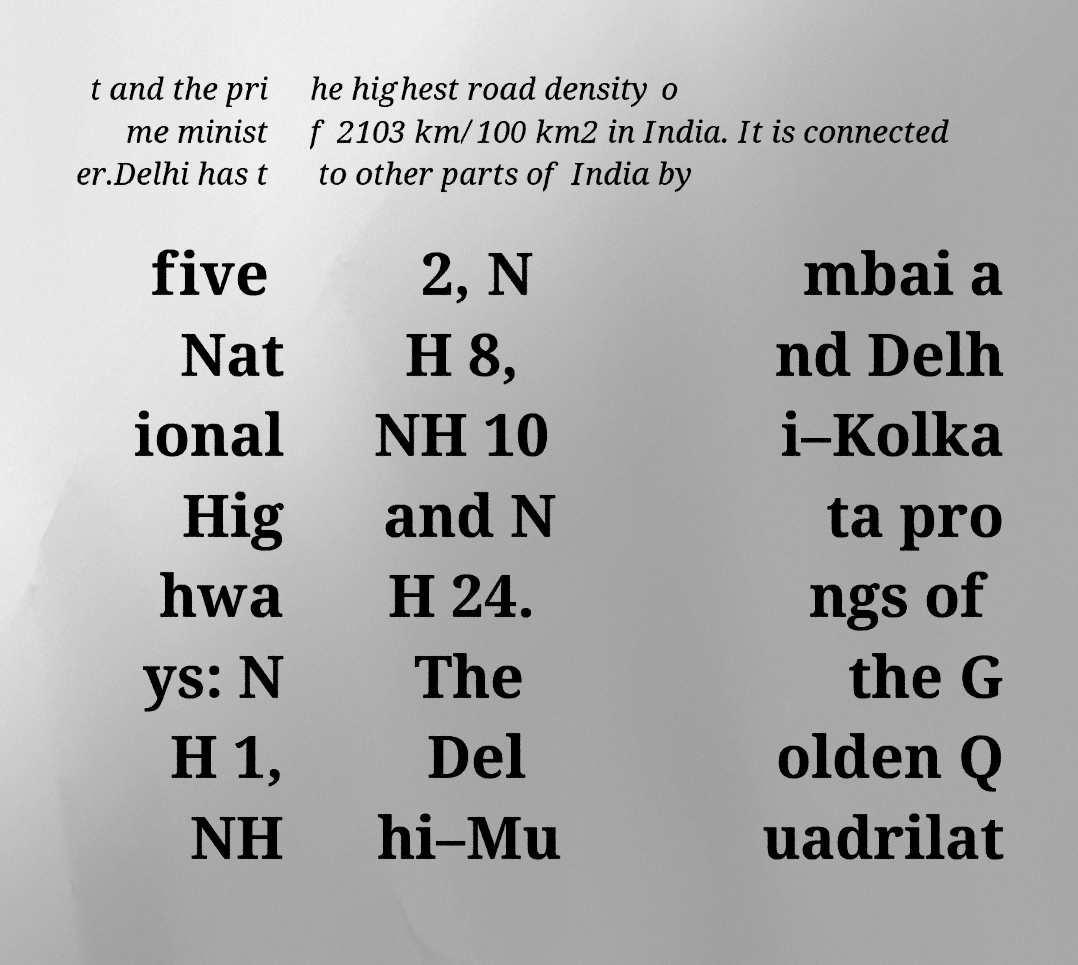Can you read and provide the text displayed in the image?This photo seems to have some interesting text. Can you extract and type it out for me? t and the pri me minist er.Delhi has t he highest road density o f 2103 km/100 km2 in India. It is connected to other parts of India by five Nat ional Hig hwa ys: N H 1, NH 2, N H 8, NH 10 and N H 24. The Del hi–Mu mbai a nd Delh i–Kolka ta pro ngs of the G olden Q uadrilat 